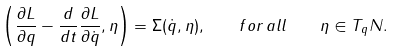Convert formula to latex. <formula><loc_0><loc_0><loc_500><loc_500>\left ( \frac { \partial L } { \partial q } - \frac { d } { d t } \frac { \partial L } { \partial \dot { q } } , \eta \right ) = \Sigma ( \dot { q } , \eta ) , \quad f o r \, a l l \quad \eta \in T _ { q } N .</formula> 